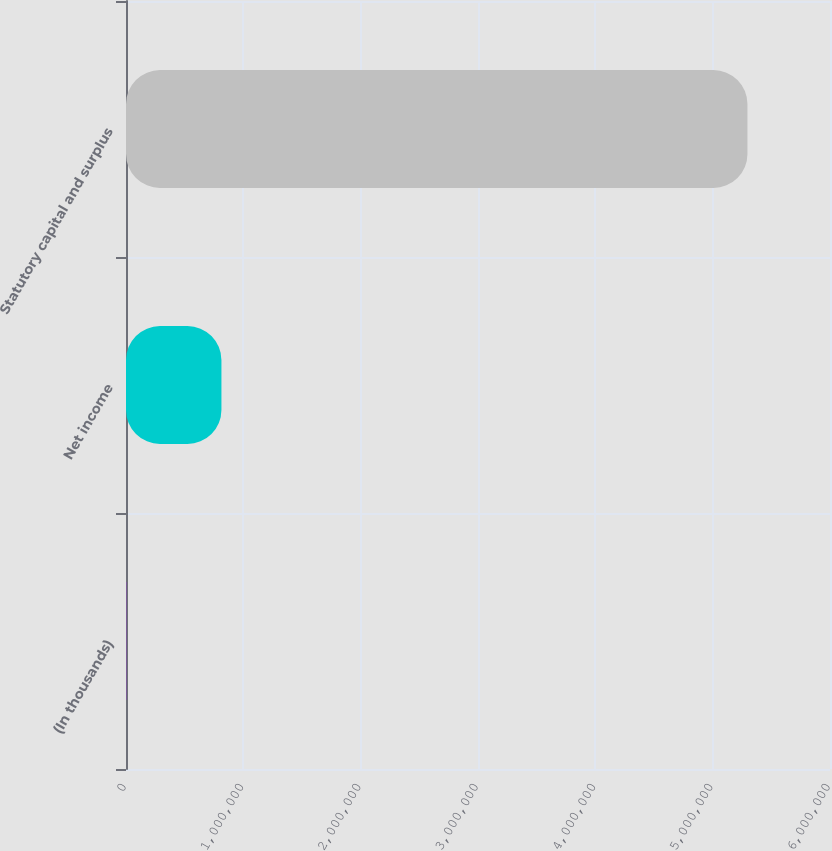<chart> <loc_0><loc_0><loc_500><loc_500><bar_chart><fcel>(In thousands)<fcel>Net income<fcel>Statutory capital and surplus<nl><fcel>2015<fcel>813303<fcel>5.29644e+06<nl></chart> 